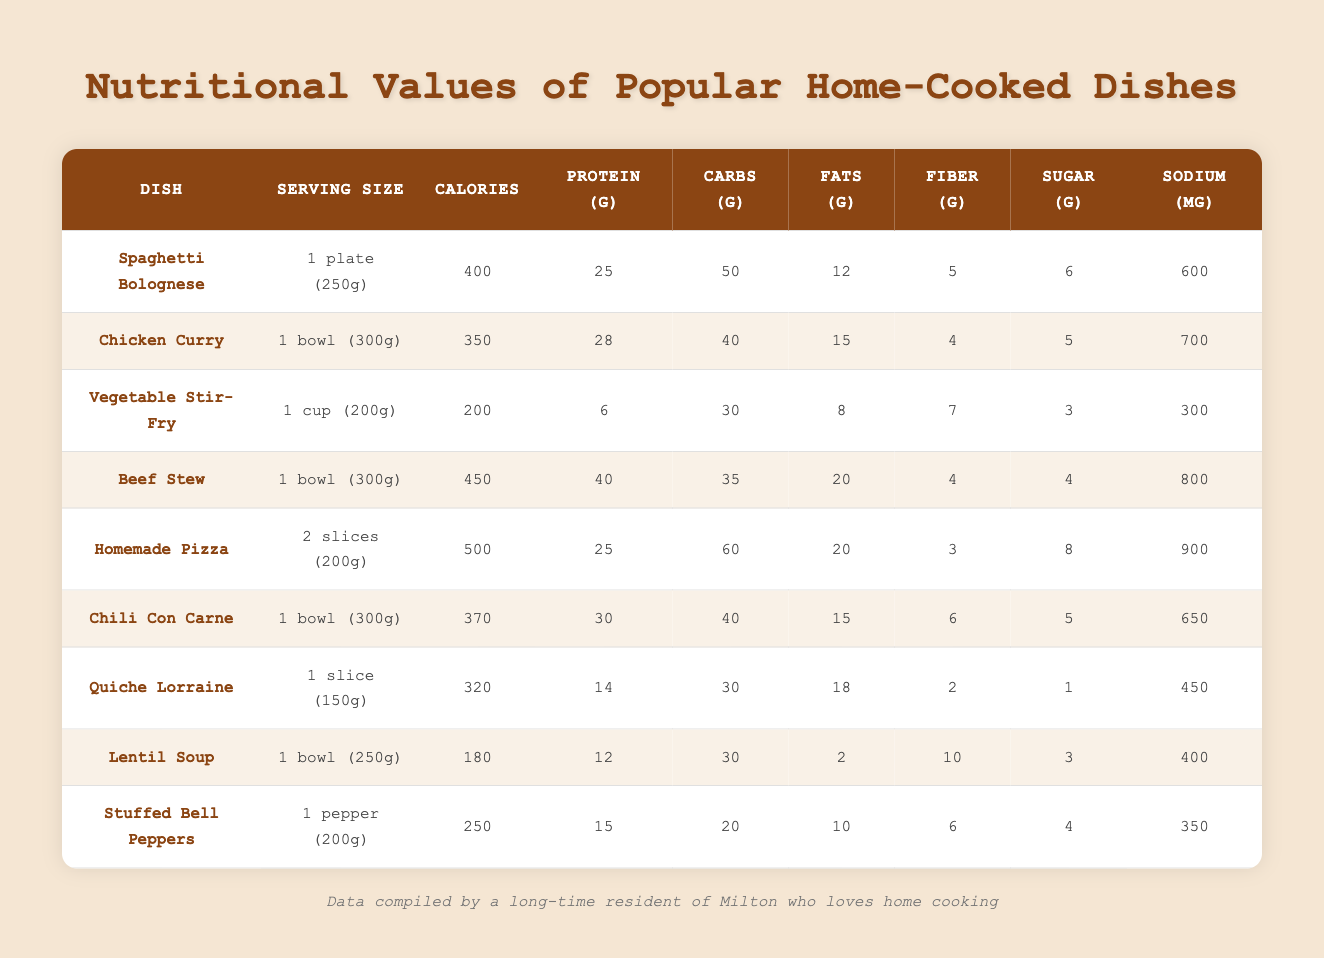What dish has the highest calories? By scanning the calories column, the dish with the highest calories is Homemade Pizza with 500 calories.
Answer: Homemade Pizza How much protein is in Chicken Curry? The protein content for Chicken Curry is listed in the protein column, which shows 28 grams.
Answer: 28 grams What is the serving size of Lentil Soup? The serving size for Lentil Soup is provided in the table, which is 1 bowl (250g).
Answer: 1 bowl (250g) Which dish has the lowest sodium content? By checking the sodium column, Lentil Soup has the lowest sodium content at 400 mg.
Answer: Lentil Soup How many grams of carbohydrates are in Beef Stew? The carbohydrates for Beef Stew are directly indicated in the carbs column, which is 35 grams.
Answer: 35 grams What is the total calorie content of Spaghetti Bolognese and Chili Con Carne? To find the total calories, we add the calorie content of both dishes: 400 (Spaghetti Bolognese) + 370 (Chili Con Carne) = 770 calories.
Answer: 770 calories How much fiber do vegetable dishes have on average? We consider the fiber content of Vegetable Stir-Fry (7g) and Stuffed Bell Peppers (6g). The average is (7 + 6) / 2 = 6.5 grams.
Answer: 6.5 grams Is the protein content in Quiche Lorraine less than that in Chili Con Carne? Quiche Lorraine has 14 grams of protein, while Chili Con Carne has 30 grams. Since 14 is less than 30, the statement is true.
Answer: Yes How many more grams of fat does Homemade Pizza have compared to Vegetable Stir-Fry? The fat content for Homemade Pizza is 20 grams and for Vegetable Stir-Fry is 8 grams. The difference is 20 - 8 = 12 grams.
Answer: 12 grams Which dish contains more fiber, Lentil Soup or Chili Con Carne? Lentil Soup has 10 grams of fiber while Chili Con Carne has 6 grams. Since 10 is greater than 6, Lentil Soup has more fiber.
Answer: Lentil Soup What is the average calorie content of all dishes listed? To find the average, we sum all the calories: 400 + 350 + 200 + 450 + 500 + 370 + 320 + 180 + 250 = 3020 calories. There are 9 dishes, so 3020 / 9 = 335.56, rounded to 336.
Answer: 336 calories 